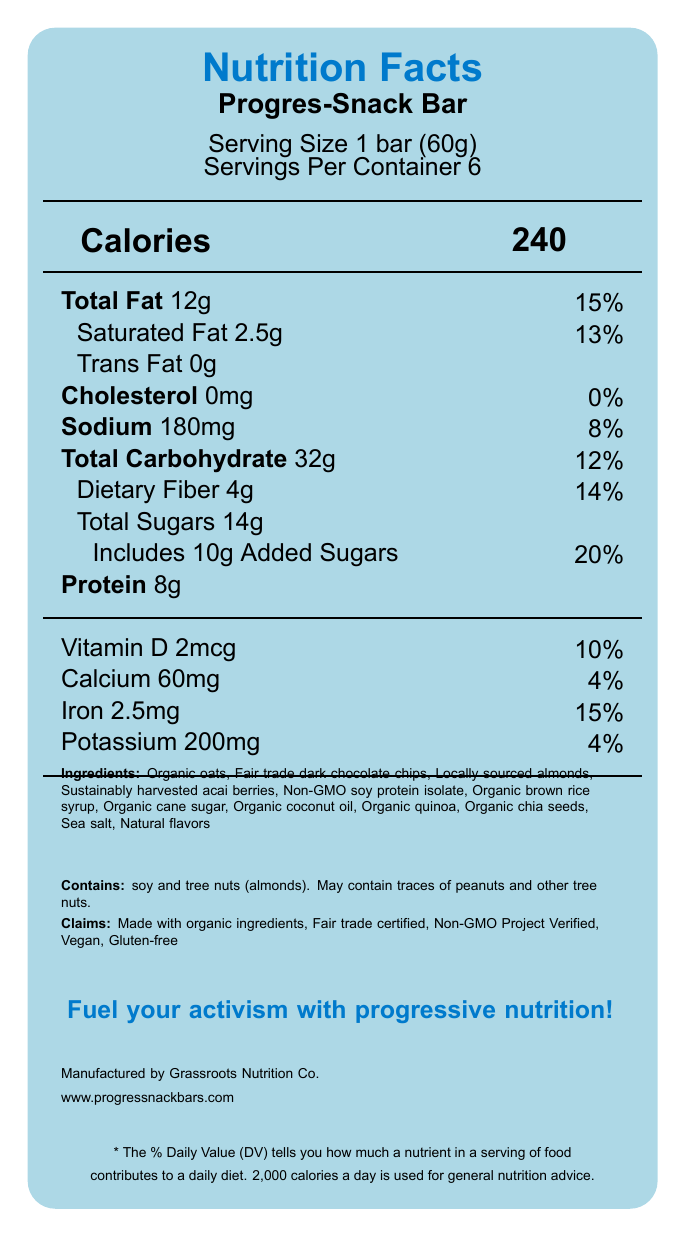what is the serving size of the Progres-Snack Bar? The serving size is explicitly mentioned as "1 bar (60g)" in the document.
Answer: 1 bar (60g) how many servings are in one container? The document states there are "6 servings per container".
Answer: 6 servings how much protein is in a single Progres-Snack Bar? The protein content is listed as "8g" for one serving.
Answer: 8g what is the daily value percentage for added sugars? The daily value percentage for added sugars is shown as "20%".
Answer: 20% what is the amount of dietary fiber per serving? The document specifies that each serving contains "4g" of dietary fiber.
Answer: 4g which ingredient in the Progres-Snack Bar provides omega-3 fatty acids? A. Fair trade dark chocolate chips B. Acai berries C. Chia seeds D. Organic oats The document mentions that chia seeds are included for their omega-3 fatty acids.
Answer: C. Chia seeds what is the total carbohydrate content in a single serving? A. 20g B. 32g C. 25g D. 14g The total carbohydrate content is listed as "32g" per serving.
Answer: B. 32g is this product vegan? The document contains a marketing claim stating the Progres-Snack Bar is "Vegan".
Answer: Yes what is the main idea of the document? The document highlights the nutritional profile, ingredients list, allergen information, and marketing claims surrounding the Progres-Snack Bar, with an emphasis on its progressive and sustainable values.
Answer: The document provides nutritional information, ingredients, allergen details, and marketing claims for the Progres-Snack Bar, a politically-themed energy bar made with organic, fair trade, and non-GMO ingredients, designed to fuel activism. what is the amount of cholesterol per serving? The document specifies that each serving contains "0mg" of cholesterol.
Answer: 0mg how is the sodium content listed in the document? The sodium content is listed as "180mg" per serving with a daily value percentage of 8%.
Answer: 180mg which company manufactures the Progres-Snack Bar? The manufacturer is listed as "Grassroots Nutrition Co.".
Answer: Grassroots Nutrition Co. does the Progres-Snack Bar contain any tree nuts? The allergen information states that the product contains tree nuts (almonds).
Answer: Yes is enough information provided to determine if the Progres-Snack Bar is low in sodium? The document provides the sodium content (180mg, 8% DV), but does not specify the criteria for being considered low in sodium.
Answer: No, not enough information what is the political slogan for the Progres-Snack Bar? The slogan is clearly stated at the bottom of the document in bold blue text.
Answer: Fuel your activism with progressive nutrition! 